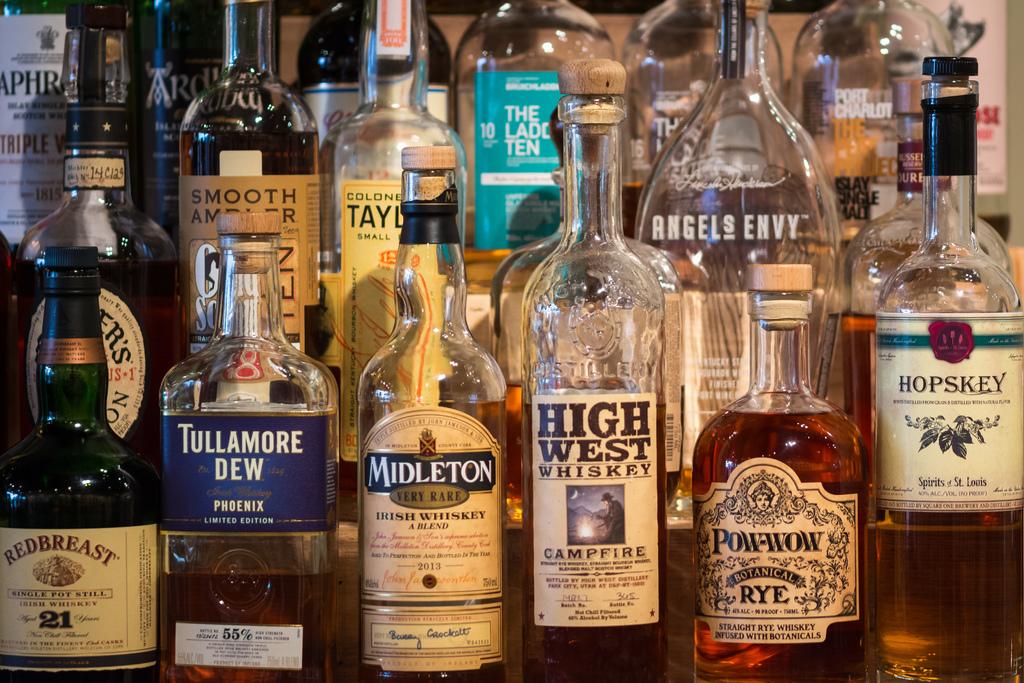Where is hopskey whiskey made?
Provide a succinct answer. St. louis. What brand is on the bottle on the front right?
Offer a very short reply. Hopskey. 